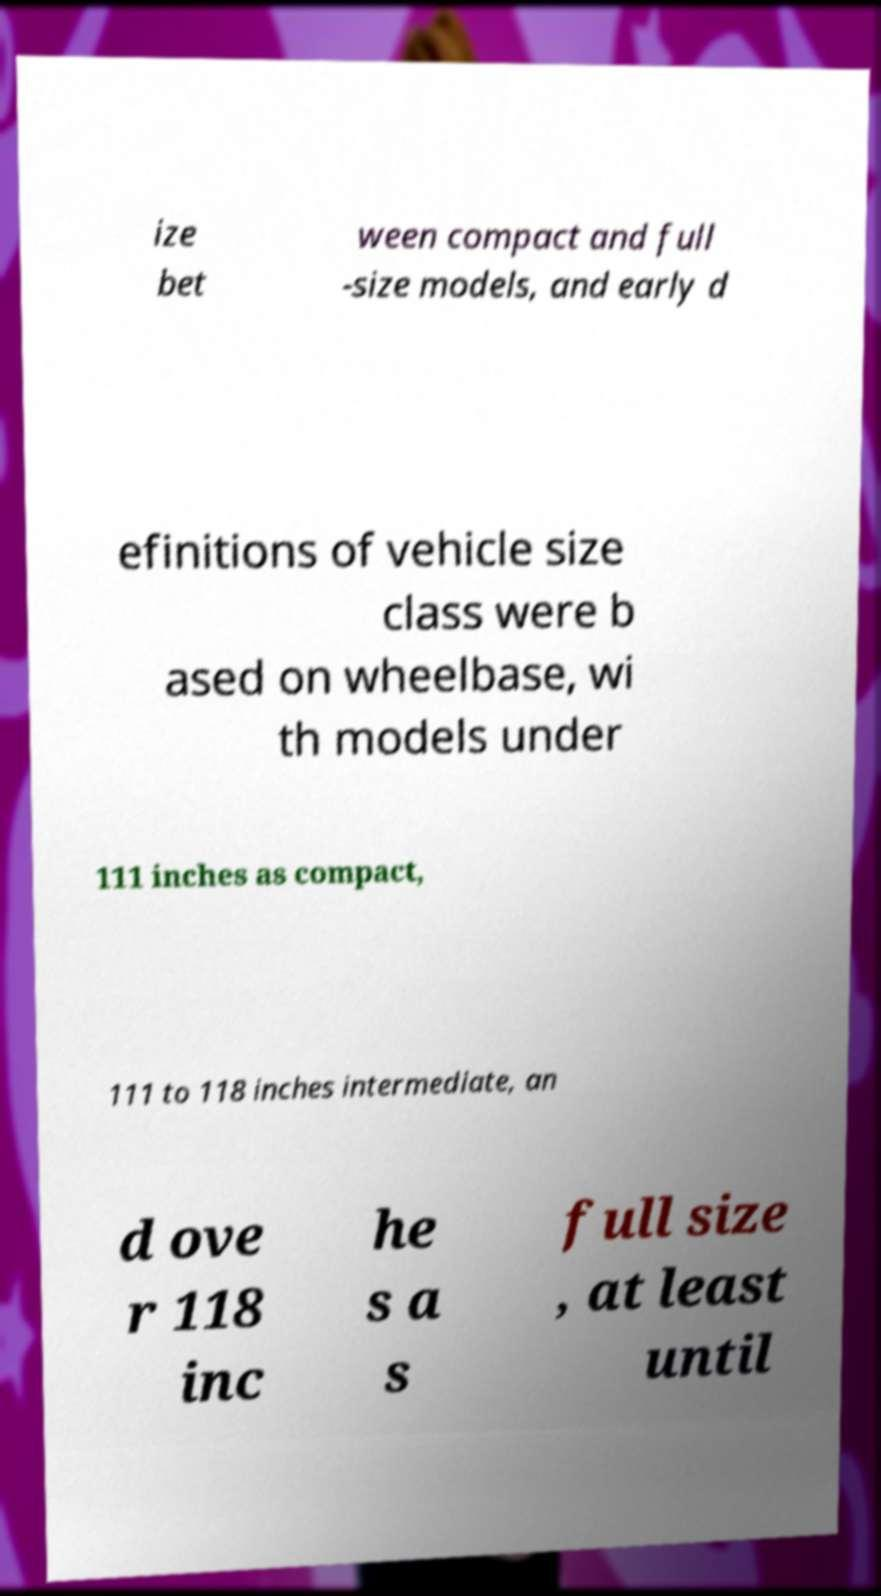Please identify and transcribe the text found in this image. ize bet ween compact and full -size models, and early d efinitions of vehicle size class were b ased on wheelbase, wi th models under 111 inches as compact, 111 to 118 inches intermediate, an d ove r 118 inc he s a s full size , at least until 